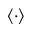Convert formula to latex. <formula><loc_0><loc_0><loc_500><loc_500>\langle \cdot \rangle</formula> 